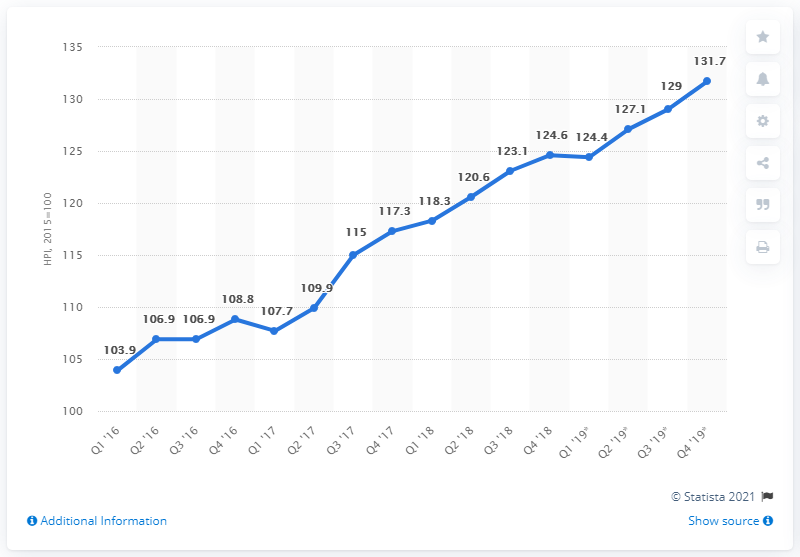Point out several critical features in this image. In the fourth quarter of 2019, the house price index for dwellings in Germany was 131.7. In the fourth quarter of 2017, the recorded value was 117.3... The latest 3 data points are averaged to give an average of 129.267.... 